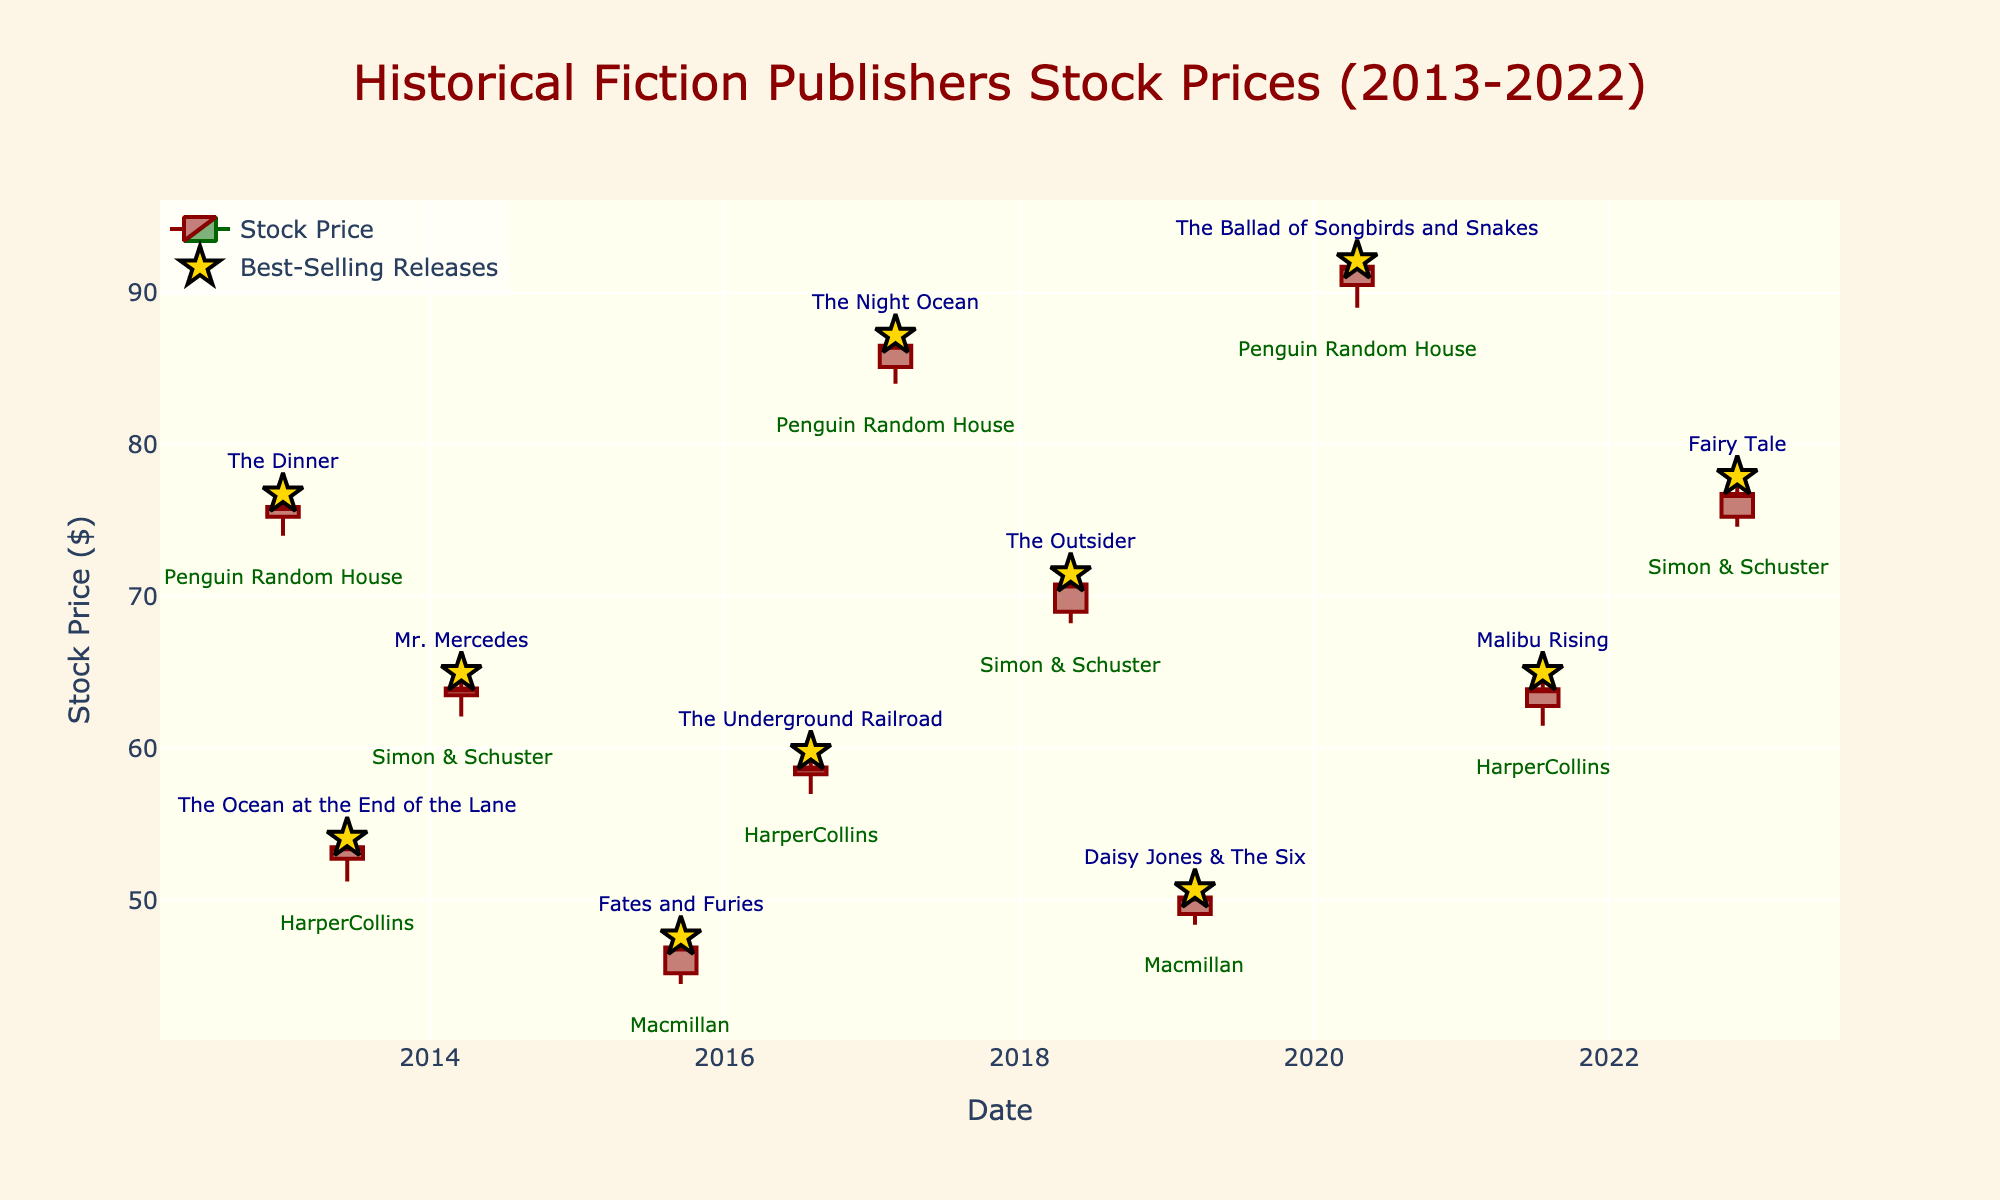What is the title of the figure? The title is usually displayed prominently at the top of the figure. In this case, the title of the figure is "Historical Fiction Publishers Stock Prices (2013-2022)." By reading the text at the top center of the figure, you can identify the title.
Answer: Historical Fiction Publishers Stock Prices (2013-2022) How many data points are marked with stars? Stars usually represent special data points, indicating major events. In the figure, you need to count the number of star markers used to indicate best-selling releases. There are 10 points marked with stars, each corresponding to a best-selling release.
Answer: 10 What was the highest stock price for HarperCollins during the decade? To find the highest stock price for HarperCollins, look for the all-time high price indicated by the "High" values associated with the dates HarperCollins had a best-selling release. The highest price for HarperCollins is $65.00, which occurred on 2021-07-21.
Answer: $65.00 Which publisher had the highest closing stock price, and what was it? Identify the highest closing stock price by comparing the "Close" values of all publishers. Penguin Random House had the highest closing stock price of $91.70, which occurred on 2020-04-17.
Answer: Penguin Random House, $91.70 Which year had the most best-selling releases, and how many were there? Examine the dates of all best-selling releases and count the number of releases in each year. The year with the most best-selling releases is 2013, with 2 releases (The Dinner and The Ocean at the End of the Lane).
Answer: 2013, 2 What was the closing stock price of Simon & Schuster when "Fairy Tale" was released? Look for the release of "Fairy Tale" in the chart, specifically noting the date and publisher. "Fairy Tale" was released by Simon & Schuster on 2022-11-15, and the closing stock price on that date was $76.75.
Answer: $76.75 How many publishers are represented in the figure? Count the unique publishers noted in the annotations for the figure. There are four unique publishers represented: Penguin Random House, HarperCollins, Simon & Schuster, and Macmillan.
Answer: 4 What is the difference between the highest and lowest closing prices recorded by Macmillan? Identify the highest and lowest closing prices for Macmillan from the provided data. Subtract the lowest closing price from the highest closing price for Macmillan. The highest closing price for Macmillan is $50.20, and the lowest is $46.90, resulting in a difference of $3.30.
Answer: $3.30 